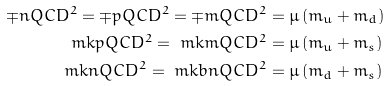<formula> <loc_0><loc_0><loc_500><loc_500>\mp n Q C D ^ { 2 } = \mp p Q C D ^ { 2 } = \mp m Q C D ^ { 2 } & = \mu \left ( m _ { u } + m _ { d } \right ) \\ \ m k p Q C D ^ { 2 } = \ m k m Q C D ^ { 2 } & = \mu \left ( m _ { u } + m _ { s } \right ) \\ \ m k n Q C D ^ { 2 } = \ m k b n Q C D ^ { 2 } & = \mu \left ( m _ { d } + m _ { s } \right )</formula> 